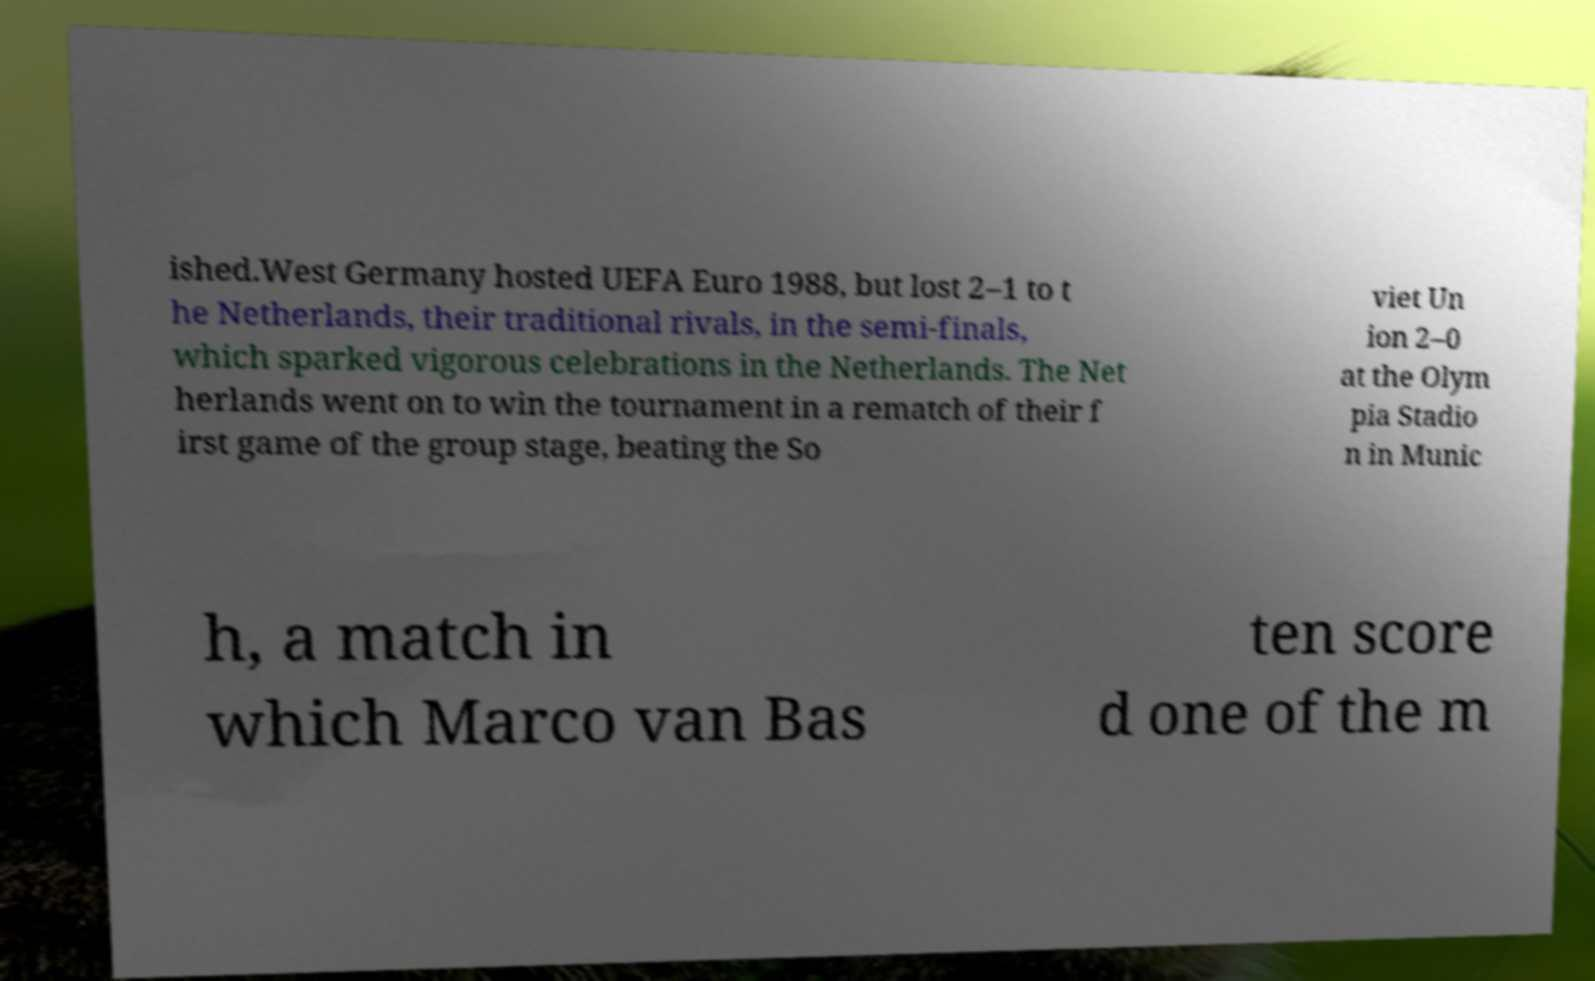Could you extract and type out the text from this image? ished.West Germany hosted UEFA Euro 1988, but lost 2–1 to t he Netherlands, their traditional rivals, in the semi-finals, which sparked vigorous celebrations in the Netherlands. The Net herlands went on to win the tournament in a rematch of their f irst game of the group stage, beating the So viet Un ion 2–0 at the Olym pia Stadio n in Munic h, a match in which Marco van Bas ten score d one of the m 